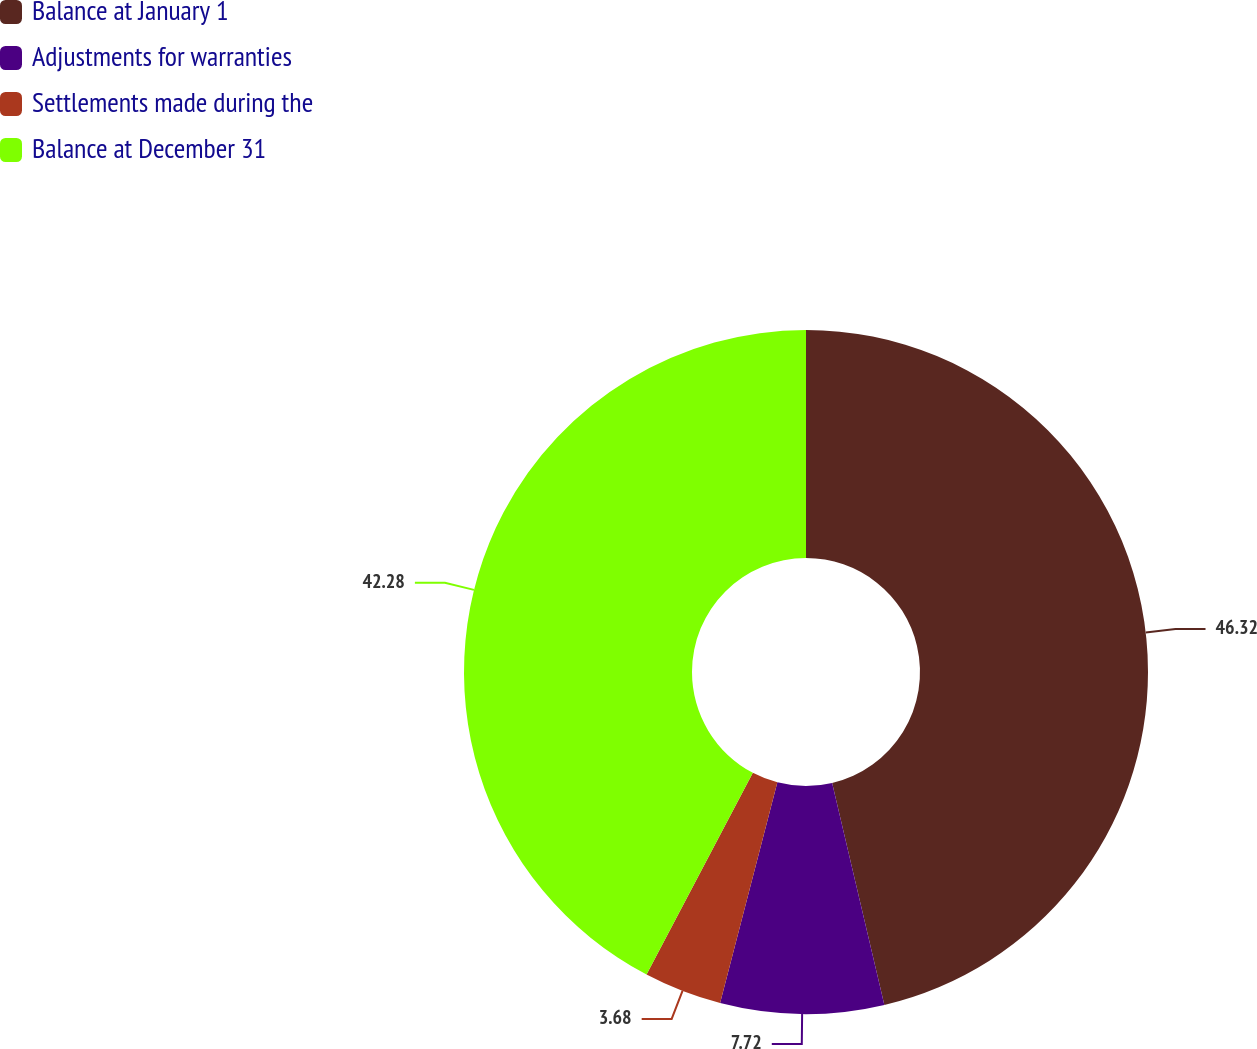Convert chart to OTSL. <chart><loc_0><loc_0><loc_500><loc_500><pie_chart><fcel>Balance at January 1<fcel>Adjustments for warranties<fcel>Settlements made during the<fcel>Balance at December 31<nl><fcel>46.32%<fcel>7.72%<fcel>3.68%<fcel>42.28%<nl></chart> 